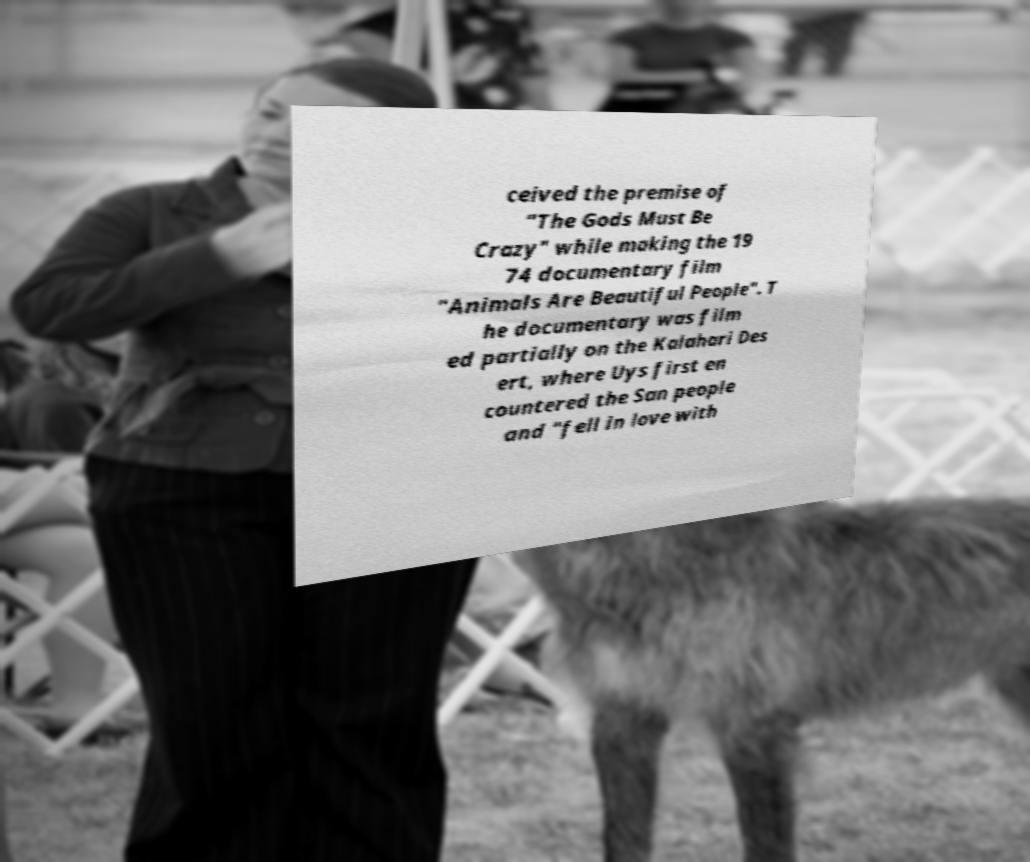Can you accurately transcribe the text from the provided image for me? ceived the premise of "The Gods Must Be Crazy" while making the 19 74 documentary film "Animals Are Beautiful People". T he documentary was film ed partially on the Kalahari Des ert, where Uys first en countered the San people and "fell in love with 